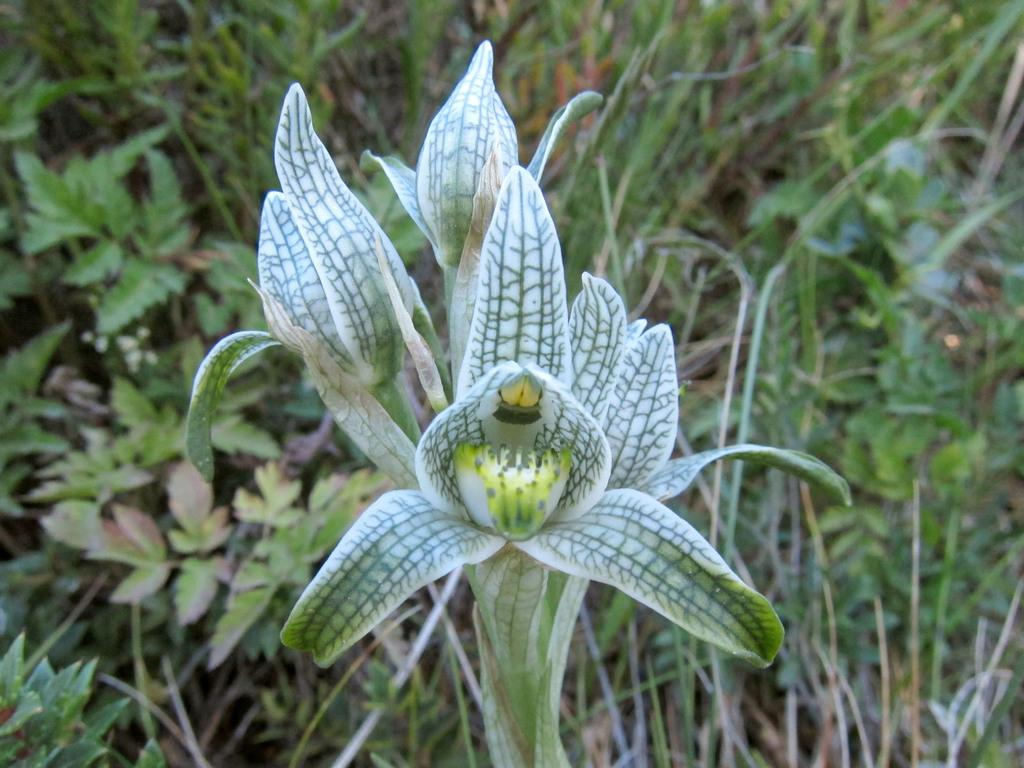What type of plant is in the image? There is a wild flower in the image. What can be seen in the background of the image? There is green grass in the background of the image. What other plant features are visible in the image? There are green leaves visible in the image. Can you see any berries growing on the wild flower in the image? There are no berries visible on the wild flower in the image. 